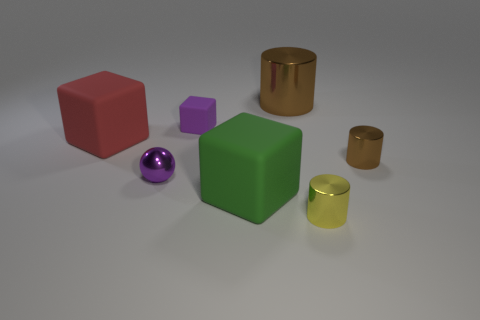What color is the object that is to the right of the large green matte thing and in front of the tiny shiny ball?
Keep it short and to the point. Yellow. What is the size of the red thing to the left of the tiny matte block?
Your answer should be compact. Large. What number of big red things are made of the same material as the yellow object?
Offer a terse response. 0. What shape is the small metallic thing that is the same color as the small rubber block?
Offer a terse response. Sphere. There is a large thing to the left of the big green matte cube; is it the same shape as the small yellow metal thing?
Your answer should be compact. No. There is a tiny thing that is the same material as the big green cube; what color is it?
Make the answer very short. Purple. There is a large object that is behind the block left of the purple metal object; are there any big green rubber objects that are behind it?
Provide a short and direct response. No. The green thing has what shape?
Your answer should be compact. Cube. Are there fewer cylinders left of the tiny sphere than brown cylinders?
Your response must be concise. Yes. Is there another brown object of the same shape as the tiny rubber object?
Keep it short and to the point. No. 